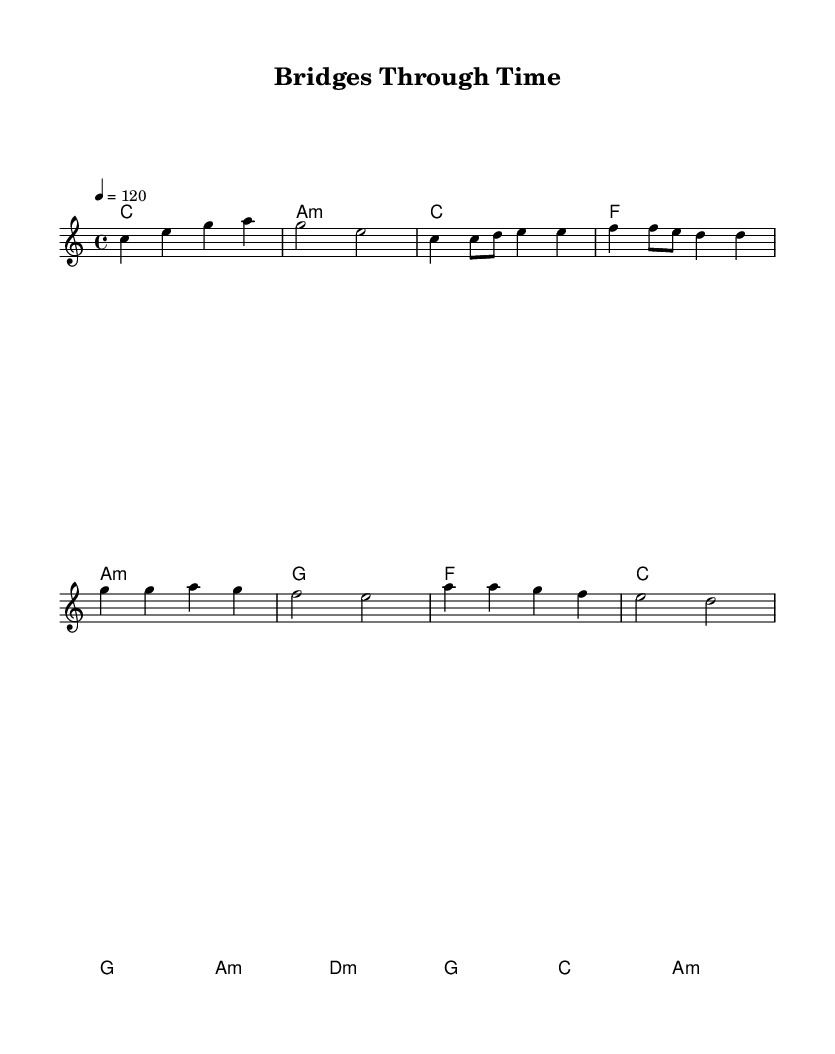What is the key signature of this music? The key signature is C major, which has no sharps or flats.
Answer: C major What is the time signature of the piece? The time signature is indicated as 4/4, meaning there are four beats per measure.
Answer: 4/4 What is the tempo marking of this music? The tempo marking is set at a quarter note equals 120 beats per minute, indicating a moderately fast pace.
Answer: 120 How many measures are in the chorus section? The chorus contains four measures, as each line of lyrics corresponds to a measure of music.
Answer: 4 What chord follows the G chord in the verse? The chord progression in the verse shows that the chord following G is A minor.
Answer: A minor Which lyrical theme is represented in the chorus? The chorus emphasizes unity and strength through collaboration across generations in music, as indicated by the lyrics.
Answer: Bridging generations What is the purpose of the bridge in this piece? The bridge serves to contrast with the verse and chorus, providing a different emotional and musical moment before returning to familiar material.
Answer: Contrast 